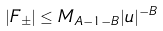<formula> <loc_0><loc_0><loc_500><loc_500>| F _ { \pm } | \leq M _ { A - 1 - B } | u | ^ { - B }</formula> 